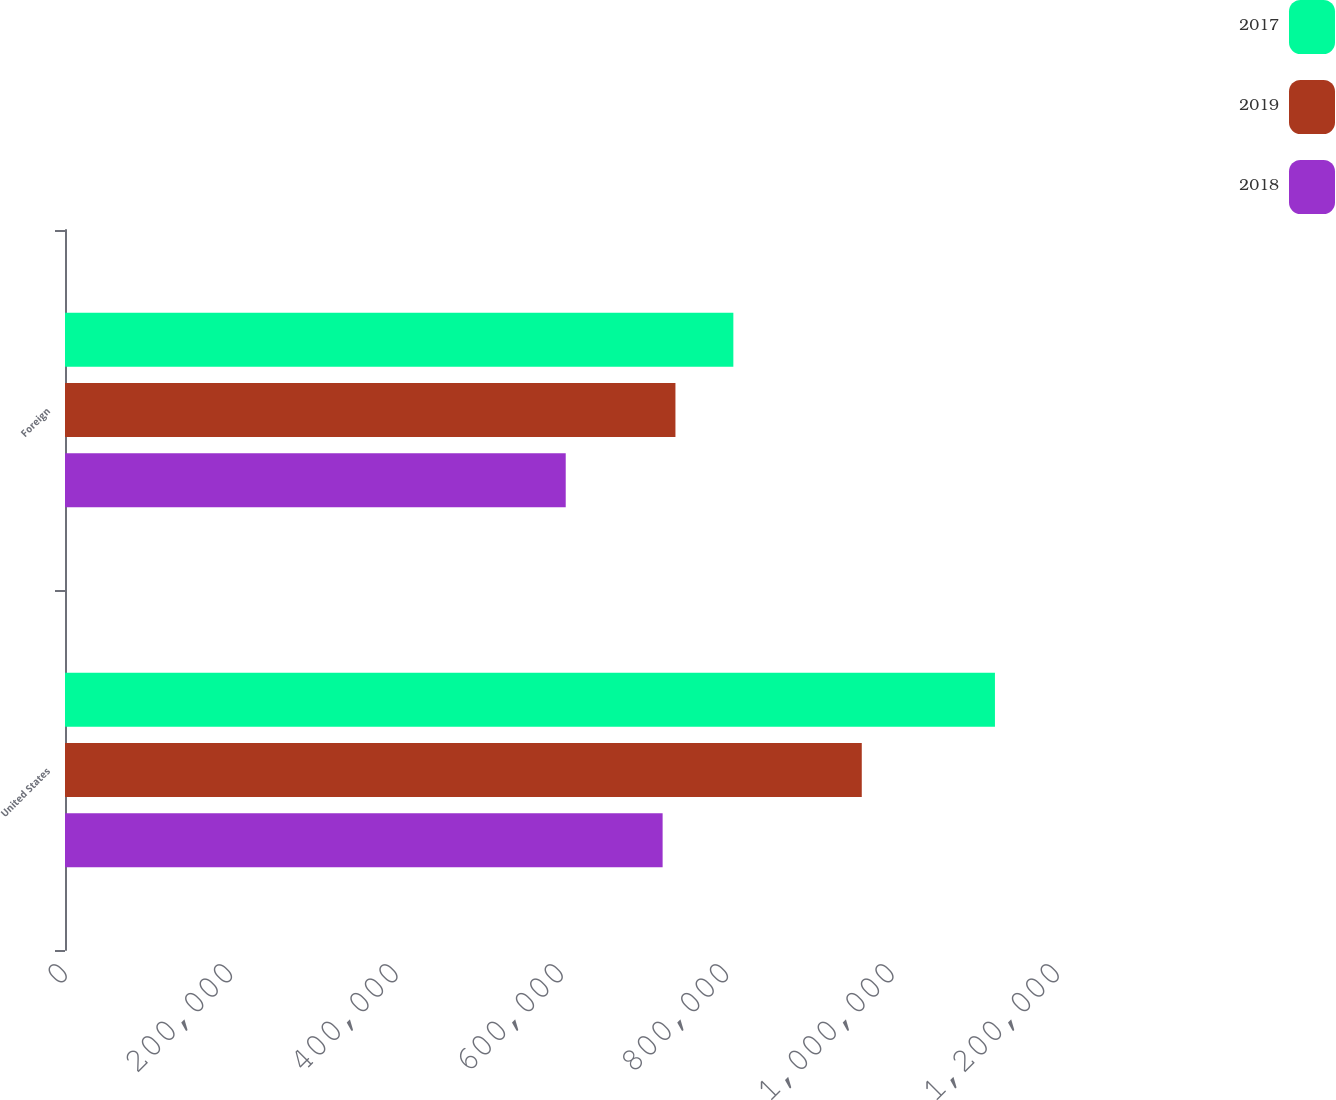Convert chart to OTSL. <chart><loc_0><loc_0><loc_500><loc_500><stacked_bar_chart><ecel><fcel>United States<fcel>Foreign<nl><fcel>2017<fcel>1.12493e+06<fcel>808492<nl><fcel>2019<fcel>963843<fcel>738434<nl><fcel>2018<fcel>722925<fcel>605716<nl></chart> 